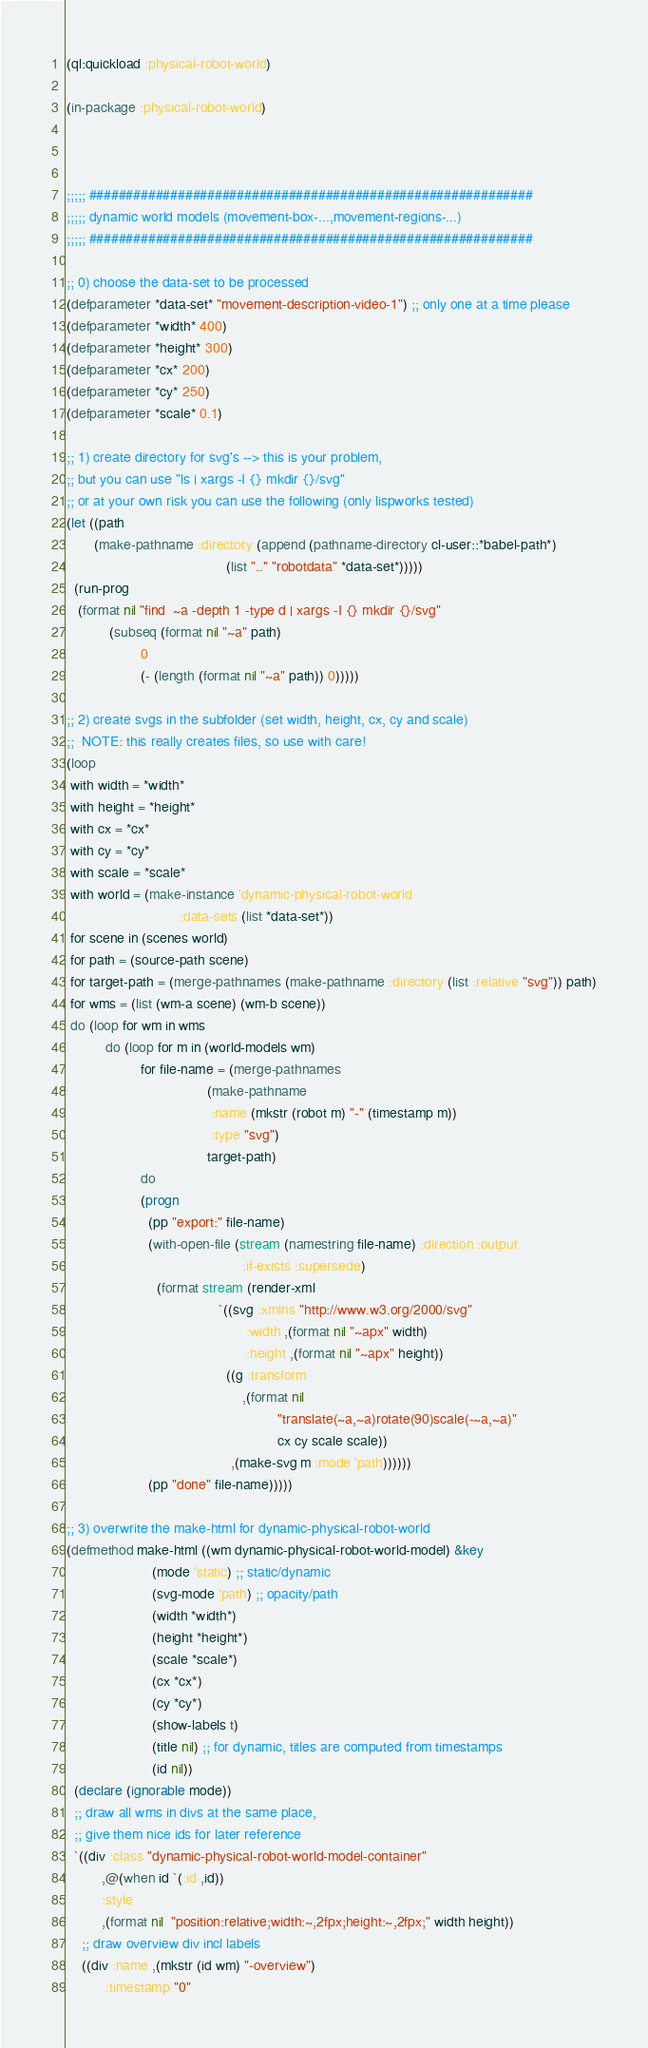Convert code to text. <code><loc_0><loc_0><loc_500><loc_500><_Lisp_>(ql:quickload :physical-robot-world)

(in-package :physical-robot-world)



;;;;; ############################################################
;;;;; dynamic world models (movement-box-...,movement-regions-...)
;;;;; ############################################################

;; 0) choose the data-set to be processed
(defparameter *data-set* "movement-description-video-1") ;; only one at a time please
(defparameter *width* 400)
(defparameter *height* 300)
(defparameter *cx* 200)
(defparameter *cy* 250)
(defparameter *scale* 0.1)

;; 1) create directory for svg's --> this is your problem,
;; but you can use "ls | xargs -I {} mkdir {}/svg"
;; or at your own risk you can use the following (only lispworks tested)
(let ((path
       (make-pathname :directory (append (pathname-directory cl-user::*babel-path*)
                                         (list ".." "robotdata" *data-set*)))))
  (run-prog
   (format nil "find  ~a -depth 1 -type d | xargs -I {} mkdir {}/svg" 
           (subseq (format nil "~a" path)
                   0
                   (- (length (format nil "~a" path)) 0)))))
               
;; 2) create svgs in the subfolder (set width, height, cx, cy and scale)
;;  NOTE: this really creates files, so use with care!
(loop
 with width = *width*
 with height = *height*
 with cx = *cx*
 with cy = *cy*
 with scale = *scale*
 with world = (make-instance 'dynamic-physical-robot-world
                             :data-sets (list *data-set*))
 for scene in (scenes world)
 for path = (source-path scene)
 for target-path = (merge-pathnames (make-pathname :directory (list :relative "svg")) path)
 for wms = (list (wm-a scene) (wm-b scene))
 do (loop for wm in wms
          do (loop for m in (world-models wm)
                   for file-name = (merge-pathnames
                                    (make-pathname
                                     :name (mkstr (robot m) "-" (timestamp m))
                                     :type "svg")
                                    target-path)
                   do
                   (progn
                     (pp "export:" file-name)
                     (with-open-file (stream (namestring file-name) :direction :output
                                             :if-exists :supersede)
                       (format stream (render-xml
                                       `((svg :xmlns "http://www.w3.org/2000/svg"
                                              :width ,(format nil "~apx" width)
                                              :height ,(format nil "~apx" height))
                                         ((g :transform
                                             ,(format nil
                                                      "translate(~a,~a)rotate(90)scale(-~a,~a)"
                                                      cx cy scale scale))
                                          ,(make-svg m :mode 'path))))))
                     (pp "done" file-name)))))

;; 3) overwrite the make-html for dynamic-physical-robot-world
(defmethod make-html ((wm dynamic-physical-robot-world-model) &key
                      (mode 'static) ;; static/dynamic
                      (svg-mode 'path) ;; opacity/path
                      (width *width*)
                      (height *height*)
                      (scale *scale*)
                      (cx *cx*)
                      (cy *cy*)
                      (show-labels t)
                      (title nil) ;; for dynamic, titles are computed from timestamps
                      (id nil))
  (declare (ignorable mode))
  ;; draw all wms in divs at the same place,
  ;; give them nice ids for later reference
  `((div :class "dynamic-physical-robot-world-model-container"
         ,@(when id `(:id ,id)) 
         :style
         ,(format nil  "position:relative;width:~,2fpx;height:~,2fpx;" width height))
    ;; draw overview div incl labels
    ((div :name ,(mkstr (id wm) "-overview")
          :timestamp "0"</code> 